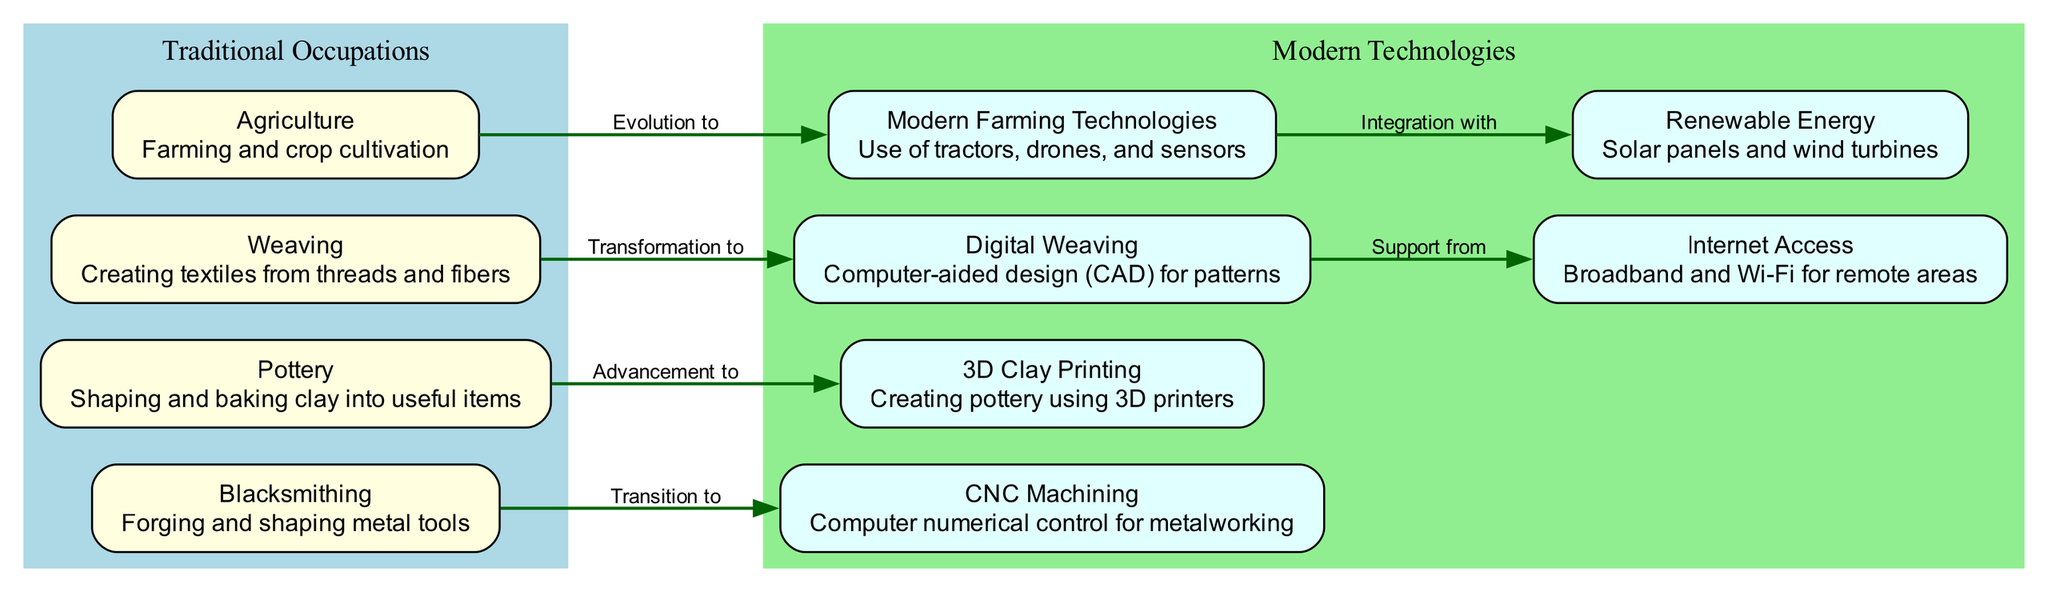What is the label of the first traditional occupation? The first traditional occupation, as represented in the diagram, is "Agriculture." This can be identified by looking at the nodes listed under the "Traditional Occupations" subgraph; the first one is Agriculture.
Answer: Agriculture What does the arrow from Weaving indicate? The arrow from Weaving indicates that it has transformed into Digital Weaving. In the diagram, this relationship is shown by the edge labeled "Transformation to."
Answer: Transformation to Digital Weaving How many modern technologies are represented in the diagram? The diagram features six modern technologies. This can be verified by counting the nodes within the "Modern Technologies" subgraph, which lists six distinct entries.
Answer: 6 What type of energy is integrated with modern farming technologies? The diagram shows that modern farming technologies integrate with Renewable Energy. This relationship is indicated by the edge that connects the two nodes.
Answer: Renewable Energy Which traditional occupation transitions to CNC Machining? The traditional occupation that transitions to CNC Machining is Blacksmithing. This is evident in the edge labeled "Transition to," which connects these two nodes in the diagram.
Answer: Blacksmithing What support does Digital Weaving receive? Digital Weaving receives support from Internet Access. This conclusion is drawn from the edge label "Support from," which shows the connection between these two nodes.
Answer: Internet Access What are the two main groups represented in the diagram? The two main groups in the diagram are Traditional Occupations and Modern Technologies. These groups are visually separated into distinct subgraphs.
Answer: Traditional Occupations and Modern Technologies What is the relationship between Modern Farming Technologies and Renewable Energy? The relationship is that Modern Farming Technologies integrates with Renewable Energy. This is evident from the edge labeled "Integration with," linking the two nodes.
Answer: Integration with Renewable Energy How many edges connect traditional occupations to modern technologies? There are four edges connecting traditional occupations to modern technologies. By examining the edges, it is clear that each traditional occupation has one connection to its respective modern technology.
Answer: 4 